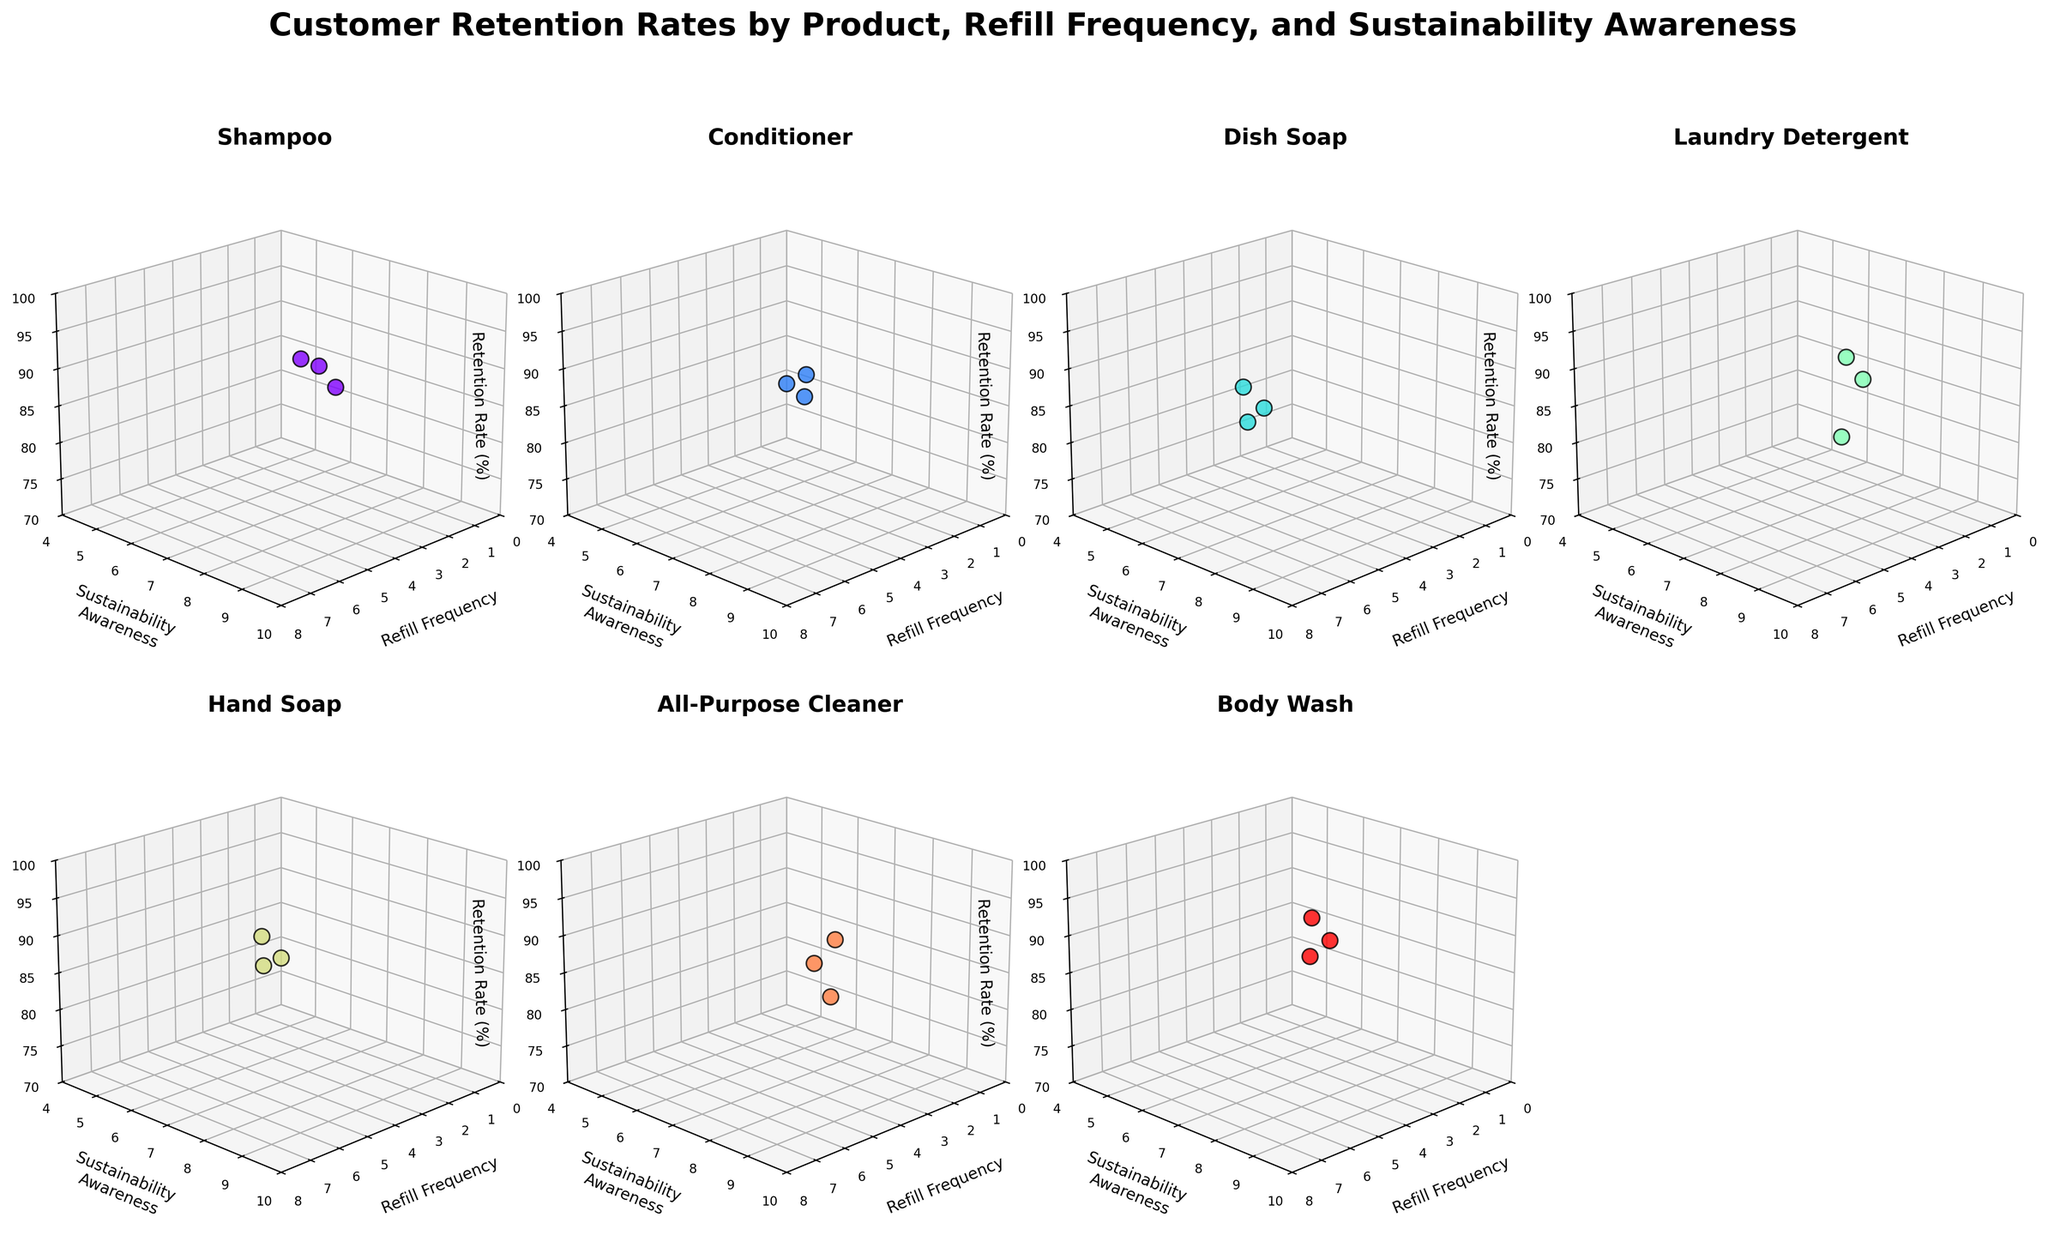What is the title of the figure? The title is located at the top of the figure as the main header.
Answer: Customer Retention Rates by Product, Refill Frequency, and Sustainability Awareness What is the retention rate for Body Wash with a refill frequency of 4? Look at the subplot for Body Wash, locate the point with a refill frequency of 4, and read its z-axis value.
Answer: 91% How does the retention rate change for Hand Soap as the refill frequency increases? In the Hand Soap subplot, compare the retention rates for refill frequencies of 2, 4, and 6. Notice the progression value.
Answer: Increases from 80% to 87% to 94% Which product has the highest retention rate for a refill frequency of 6? Compare the retention rates for a refill frequency of 6 in all subplots and identify the highest value.
Answer: Body Wash (98%) What is the average retention rate for products with a sustainability awareness level of 7? Find and sum the retention rates for all products at sustainability level 7, then divide by the number of data points with that level.
Answer: (92+88+86+87+85)/5 = 87.6% Which product has the widest range of retention rates? Identify the maximum and minimum retention rates in each subplot, then calculate the range for comparison.
Answer: Laundry Detergent (range from 75 to 96%) Is there any product with no change in retention rate as sustainability awareness increases? Check each subplot for consistency in retention rates across different sustainability awareness levels.
Answer: No, all products show a change How does the retention rate of Dish Soap with a refill frequency of 5 compare to All-Purpose Cleaner with the same frequency? Look at the retention rates for both products with a refill frequency of 5 in their respective subplots.
Answer: 86% (Dish Soap) vs. 94% (All-Purpose Cleaner) What is the retention rate difference between Shampoo and Conditioner for a sustainability awareness level of 9? In each product's subplot, find the retention rates for a sustainability awareness level of 9 and subtract one from the other.
Answer: 97% - 95% = 2% Which product has the lowest retention rate for a sustainability awareness level of 5? Identify the retention rates for sustainability awareness level 5 in the relevant subplots and determine the lowest value.
Answer: Dish Soap (78%) 